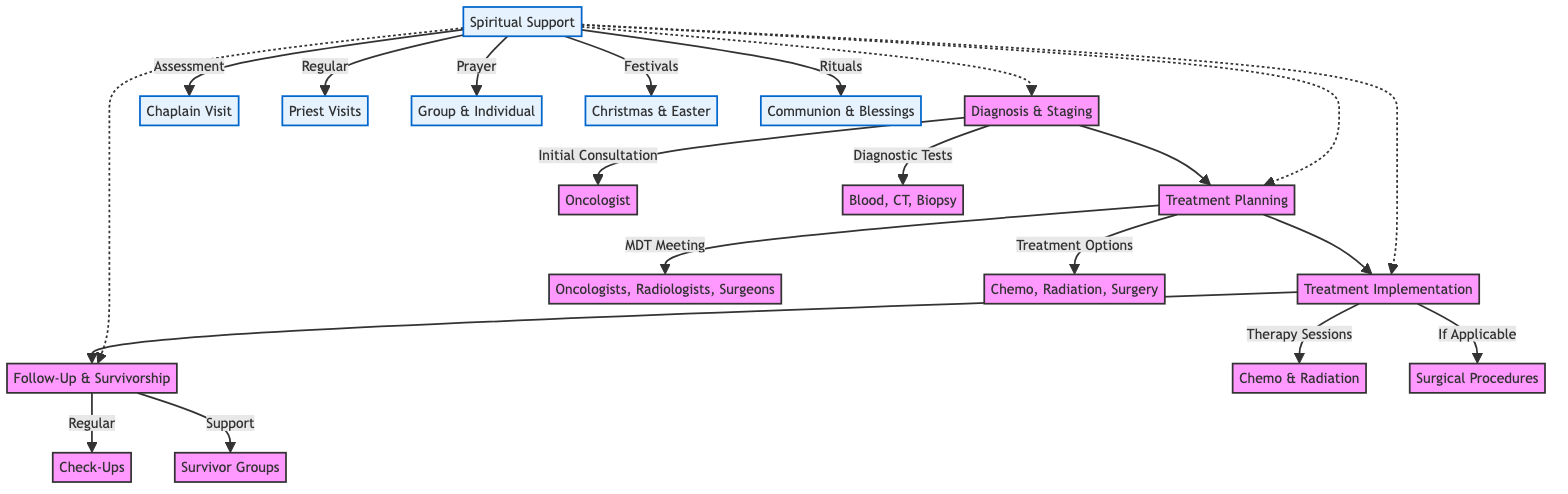What is the first step in the cancer treatment pathway? The diagram indicates that the first step is "Diagnosis & Staging," which involves the initial consultation and diagnostic tests.
Answer: Diagnosis & Staging How many treatment options are available in the treatment planning stage? The diagram lists three treatment options: chemotherapy, radiation therapy, and surgery, making a total of three.
Answer: 3 Which type of therapy sessions are scheduled in the treatment implementation phase? The diagram specifies that chemotherapy sessions and radiation therapy sessions are both scheduled during the treatment implementation phase.
Answer: Chemotherapy & Radiation What kind of spiritual support is provided during follow-up and survivorship? The follow-up and survivorship stage includes regular check-ups as well as ongoing spiritual counseling.
Answer: Regular check-ups & Spiritual counseling What is the role of the chaplain in the spiritual support section? The chaplain's role is to conduct the initial spiritual well-being assessment, as indicated in the spiritual support section of the diagram.
Answer: Initial spiritual well-being assessment Which festivals are celebrated as part of spiritual support? The diagram mentions Coptic Christmas prayers and gatherings, as well as Easter celebrations as festivals celebrated in the spiritual support section.
Answer: Coptic Christmas & Easter What does the multidisciplinary team consist of in treatment planning? The multidisciplinary team meeting consists of oncologists, radiologists, and surgeons, which is explicitly stated in the treatment planning section of the diagram.
Answer: Oncologists, Radiologists, Surgeons How are spiritual support visits scheduled? The diagram indicates that visits from church priests are scheduled, outlining a structured approach to integrating spiritual care.
Answer: Scheduled visits from church priests What follows after the treatment implementation phase? According to the flow of the diagram, the follow-up and survivorship stage directly follows the treatment implementation phase.
Answer: Follow-Up & Survivorship 